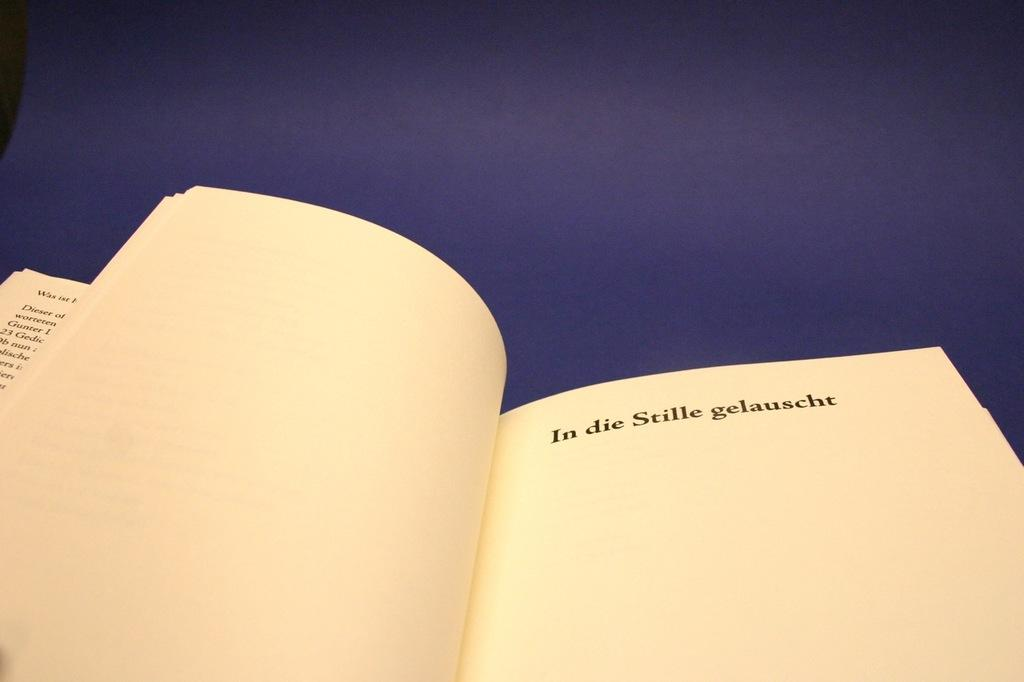<image>
Give a short and clear explanation of the subsequent image. A book flipped open to the page that says In Die Stille gelauscht. 